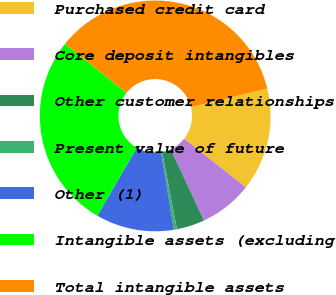Convert chart. <chart><loc_0><loc_0><loc_500><loc_500><pie_chart><fcel>Purchased credit card<fcel>Core deposit intangibles<fcel>Other customer relationships<fcel>Present value of future<fcel>Other (1)<fcel>Intangible assets (excluding<fcel>Total intangible assets<nl><fcel>14.44%<fcel>7.43%<fcel>3.93%<fcel>0.43%<fcel>10.94%<fcel>27.38%<fcel>35.45%<nl></chart> 